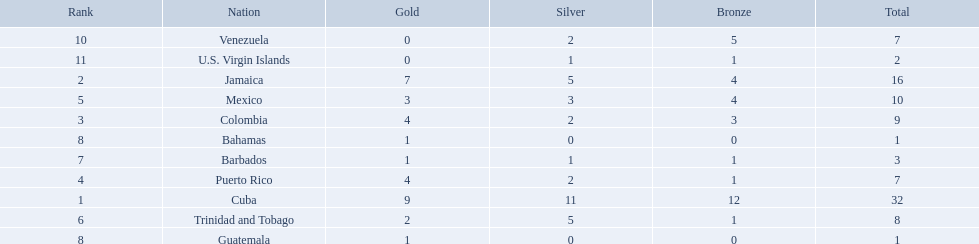Could you help me parse every detail presented in this table? {'header': ['Rank', 'Nation', 'Gold', 'Silver', 'Bronze', 'Total'], 'rows': [['10', 'Venezuela', '0', '2', '5', '7'], ['11', 'U.S. Virgin Islands', '0', '1', '1', '2'], ['2', 'Jamaica', '7', '5', '4', '16'], ['5', 'Mexico', '3', '3', '4', '10'], ['3', 'Colombia', '4', '2', '3', '9'], ['8', 'Bahamas', '1', '0', '0', '1'], ['7', 'Barbados', '1', '1', '1', '3'], ['4', 'Puerto Rico', '4', '2', '1', '7'], ['1', 'Cuba', '9', '11', '12', '32'], ['6', 'Trinidad and Tobago', '2', '5', '1', '8'], ['8', 'Guatemala', '1', '0', '0', '1']]} Which nations played in the games? Cuba, Jamaica, Colombia, Puerto Rico, Mexico, Trinidad and Tobago, Barbados, Guatemala, Bahamas, Venezuela, U.S. Virgin Islands. How many silver medals did they win? 11, 5, 2, 2, 3, 5, 1, 0, 0, 2, 1. Which team won the most silver? Cuba. 